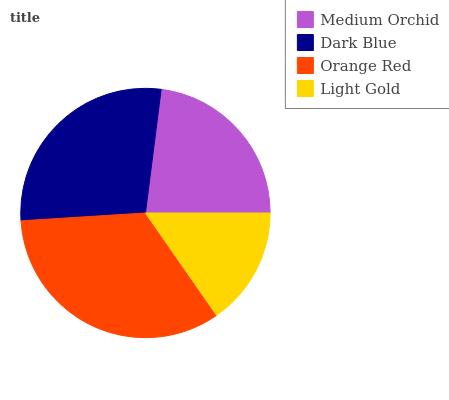Is Light Gold the minimum?
Answer yes or no. Yes. Is Orange Red the maximum?
Answer yes or no. Yes. Is Dark Blue the minimum?
Answer yes or no. No. Is Dark Blue the maximum?
Answer yes or no. No. Is Dark Blue greater than Medium Orchid?
Answer yes or no. Yes. Is Medium Orchid less than Dark Blue?
Answer yes or no. Yes. Is Medium Orchid greater than Dark Blue?
Answer yes or no. No. Is Dark Blue less than Medium Orchid?
Answer yes or no. No. Is Dark Blue the high median?
Answer yes or no. Yes. Is Medium Orchid the low median?
Answer yes or no. Yes. Is Light Gold the high median?
Answer yes or no. No. Is Orange Red the low median?
Answer yes or no. No. 